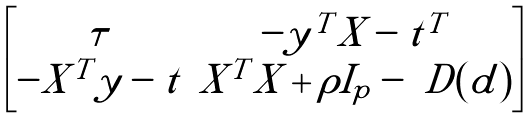<formula> <loc_0><loc_0><loc_500><loc_500>\begin{bmatrix} \tau & - y ^ { T } X - t ^ { T } \\ - X ^ { T } y - t & X ^ { T } X + \rho I _ { p } - \ D ( d ) \end{bmatrix}</formula> 